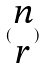Convert formula to latex. <formula><loc_0><loc_0><loc_500><loc_500>( \begin{matrix} n \\ r \end{matrix} )</formula> 